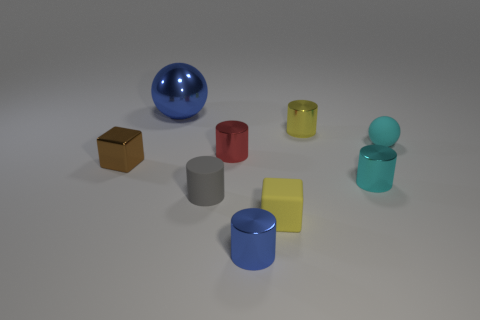Subtract all shiny cylinders. How many cylinders are left? 1 Subtract 2 spheres. How many spheres are left? 0 Subtract all balls. How many objects are left? 7 Subtract all red cylinders. How many cylinders are left? 4 Subtract 0 cyan cubes. How many objects are left? 9 Subtract all gray blocks. Subtract all purple spheres. How many blocks are left? 2 Subtract all green cubes. How many gray cylinders are left? 1 Subtract all tiny cyan matte spheres. Subtract all balls. How many objects are left? 6 Add 6 tiny matte objects. How many tiny matte objects are left? 9 Add 1 tiny gray shiny blocks. How many tiny gray shiny blocks exist? 1 